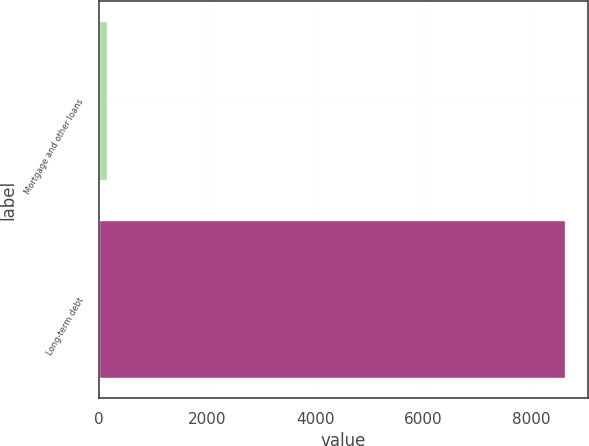Convert chart. <chart><loc_0><loc_0><loc_500><loc_500><bar_chart><fcel>Mortgage and other loans<fcel>Long-term debt<nl><fcel>150<fcel>8624<nl></chart> 